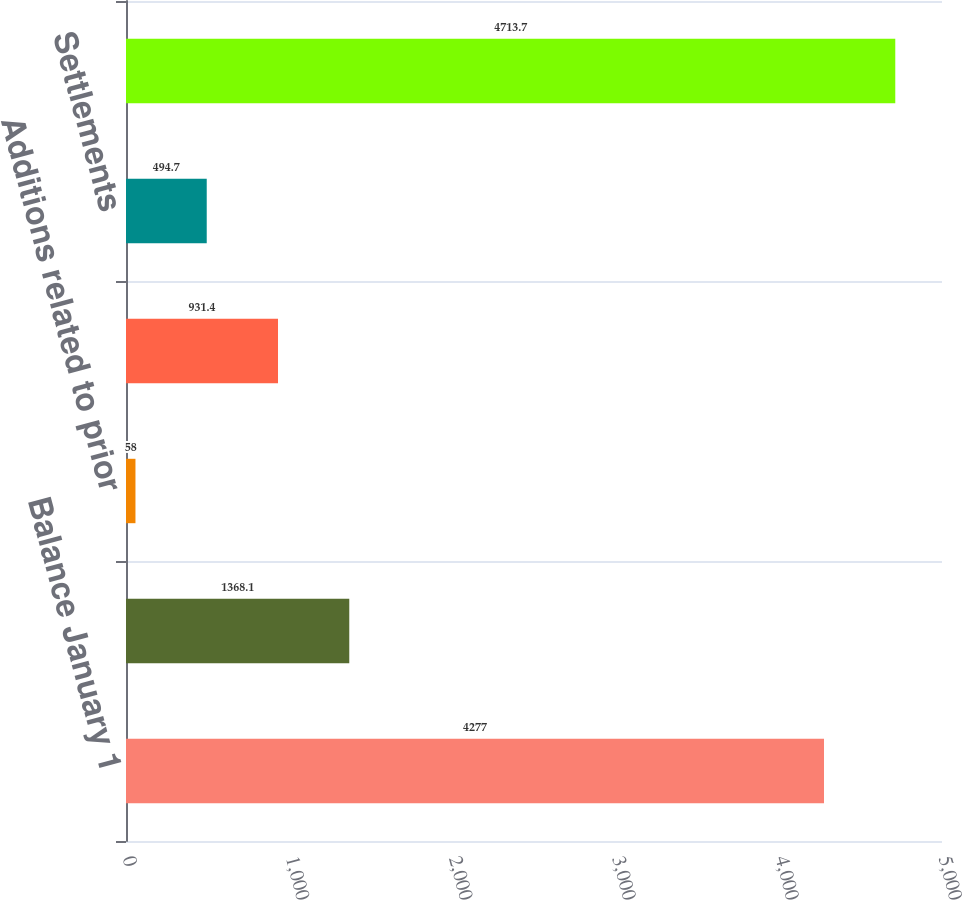<chart> <loc_0><loc_0><loc_500><loc_500><bar_chart><fcel>Balance January 1<fcel>Additions related to current<fcel>Additions related to prior<fcel>Reductions for tax positions<fcel>Settlements<fcel>Balance December 31<nl><fcel>4277<fcel>1368.1<fcel>58<fcel>931.4<fcel>494.7<fcel>4713.7<nl></chart> 